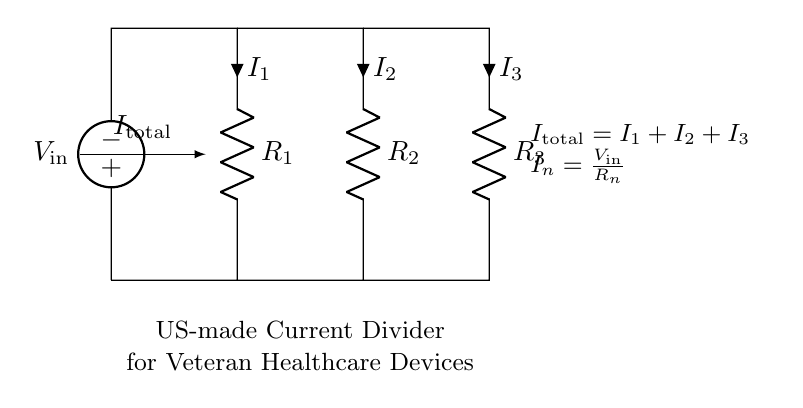What is the total current in the circuit? The total current is labeled as I total in the diagram, representing the sum of all individual currents I 1, I 2, and I 3.
Answer: I total What is the resistance of R 2? The resistance of R 2 is indicated in the diagram but without a numerical value. It is a variable resistance relative to the other resistors R 1 and R 3.
Answer: R 2 Which component determines I 1? I 1 is determined by the voltage input V in divided by the resistance R 1, as per Ohm's Law.
Answer: R 1 How does the current divide in the circuit? Current divides based on the resistance of each path; the higher the resistance, the lower the current in that branch, following the formula I n equals V in over R n.
Answer: Based on resistance What relationship do the currents I 1, I 2, and I 3 share? The currents I 1, I 2, and I 3 share a direct relationship to the input current I total, where I total equals I 1 plus I 2 plus I 3, illustrating the conservation of charge.
Answer: I total equals I 1 plus I 2 plus I 3 